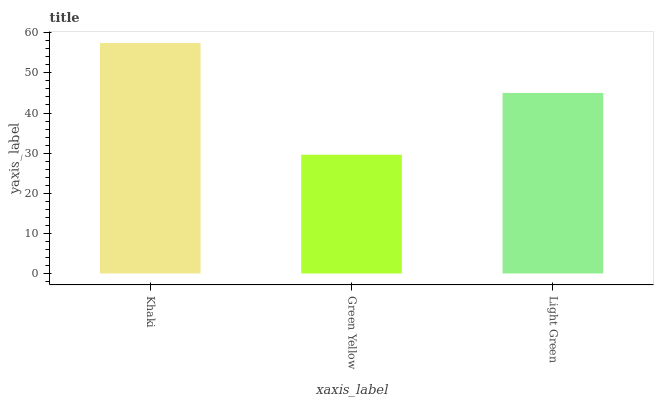Is Green Yellow the minimum?
Answer yes or no. Yes. Is Khaki the maximum?
Answer yes or no. Yes. Is Light Green the minimum?
Answer yes or no. No. Is Light Green the maximum?
Answer yes or no. No. Is Light Green greater than Green Yellow?
Answer yes or no. Yes. Is Green Yellow less than Light Green?
Answer yes or no. Yes. Is Green Yellow greater than Light Green?
Answer yes or no. No. Is Light Green less than Green Yellow?
Answer yes or no. No. Is Light Green the high median?
Answer yes or no. Yes. Is Light Green the low median?
Answer yes or no. Yes. Is Green Yellow the high median?
Answer yes or no. No. Is Green Yellow the low median?
Answer yes or no. No. 